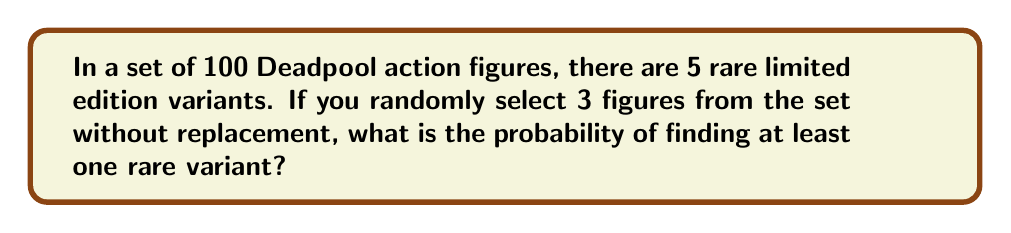Provide a solution to this math problem. Let's approach this step-by-step using the concept of complementary events:

1) First, let's calculate the probability of not selecting any rare variants.

2) The probability of not selecting a rare variant on the first draw is:
   $$P(\text{not rare on 1st}) = \frac{95}{100} = 0.95$$

3) For the second draw, given we didn't select a rare one on the first draw:
   $$P(\text{not rare on 2nd}) = \frac{94}{99} \approx 0.9495$$

4) For the third draw, given we didn't select rare ones on the first two draws:
   $$P(\text{not rare on 3rd}) = \frac{93}{98} \approx 0.9490$$

5) The probability of not selecting any rare variants in all three draws is:
   $$P(\text{no rare}) = 0.95 \times 0.9495 \times 0.9490 \approx 0.8556$$

6) Therefore, the probability of selecting at least one rare variant is:
   $$P(\text{at least one rare}) = 1 - P(\text{no rare}) = 1 - 0.8556 = 0.1444$$

7) Converting to a percentage:
   $$0.1444 \times 100\% \approx 14.44\%$$
Answer: 14.44% 